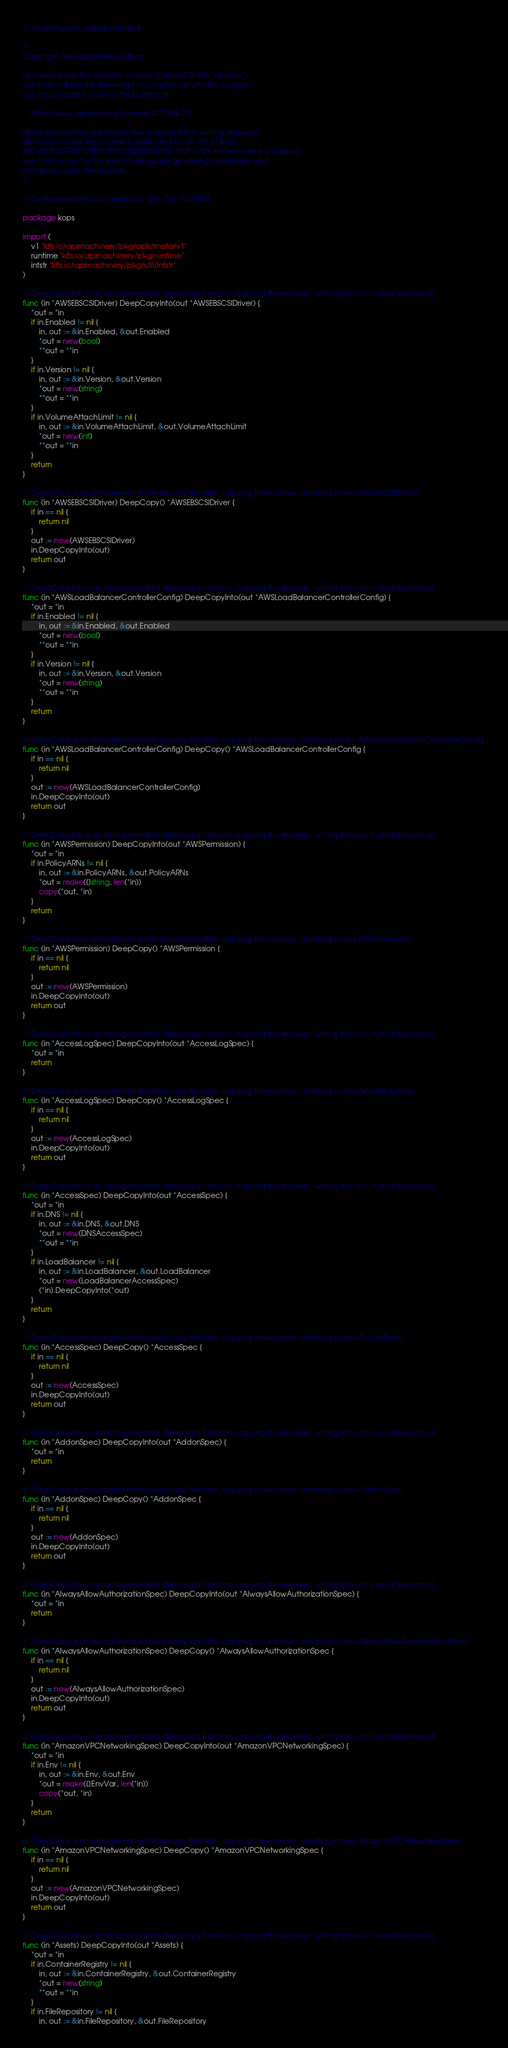Convert code to text. <code><loc_0><loc_0><loc_500><loc_500><_Go_>// +build !ignore_autogenerated

/*
Copyright The Kubernetes Authors.

Licensed under the Apache License, Version 2.0 (the "License");
you may not use this file except in compliance with the License.
You may obtain a copy of the License at

    http://www.apache.org/licenses/LICENSE-2.0

Unless required by applicable law or agreed to in writing, software
distributed under the License is distributed on an "AS IS" BASIS,
WITHOUT WARRANTIES OR CONDITIONS OF ANY KIND, either express or implied.
See the License for the specific language governing permissions and
limitations under the License.
*/

// Code generated by deepcopy-gen. DO NOT EDIT.

package kops

import (
	v1 "k8s.io/apimachinery/pkg/apis/meta/v1"
	runtime "k8s.io/apimachinery/pkg/runtime"
	intstr "k8s.io/apimachinery/pkg/util/intstr"
)

// DeepCopyInto is an autogenerated deepcopy function, copying the receiver, writing into out. in must be non-nil.
func (in *AWSEBSCSIDriver) DeepCopyInto(out *AWSEBSCSIDriver) {
	*out = *in
	if in.Enabled != nil {
		in, out := &in.Enabled, &out.Enabled
		*out = new(bool)
		**out = **in
	}
	if in.Version != nil {
		in, out := &in.Version, &out.Version
		*out = new(string)
		**out = **in
	}
	if in.VolumeAttachLimit != nil {
		in, out := &in.VolumeAttachLimit, &out.VolumeAttachLimit
		*out = new(int)
		**out = **in
	}
	return
}

// DeepCopy is an autogenerated deepcopy function, copying the receiver, creating a new AWSEBSCSIDriver.
func (in *AWSEBSCSIDriver) DeepCopy() *AWSEBSCSIDriver {
	if in == nil {
		return nil
	}
	out := new(AWSEBSCSIDriver)
	in.DeepCopyInto(out)
	return out
}

// DeepCopyInto is an autogenerated deepcopy function, copying the receiver, writing into out. in must be non-nil.
func (in *AWSLoadBalancerControllerConfig) DeepCopyInto(out *AWSLoadBalancerControllerConfig) {
	*out = *in
	if in.Enabled != nil {
		in, out := &in.Enabled, &out.Enabled
		*out = new(bool)
		**out = **in
	}
	if in.Version != nil {
		in, out := &in.Version, &out.Version
		*out = new(string)
		**out = **in
	}
	return
}

// DeepCopy is an autogenerated deepcopy function, copying the receiver, creating a new AWSLoadBalancerControllerConfig.
func (in *AWSLoadBalancerControllerConfig) DeepCopy() *AWSLoadBalancerControllerConfig {
	if in == nil {
		return nil
	}
	out := new(AWSLoadBalancerControllerConfig)
	in.DeepCopyInto(out)
	return out
}

// DeepCopyInto is an autogenerated deepcopy function, copying the receiver, writing into out. in must be non-nil.
func (in *AWSPermission) DeepCopyInto(out *AWSPermission) {
	*out = *in
	if in.PolicyARNs != nil {
		in, out := &in.PolicyARNs, &out.PolicyARNs
		*out = make([]string, len(*in))
		copy(*out, *in)
	}
	return
}

// DeepCopy is an autogenerated deepcopy function, copying the receiver, creating a new AWSPermission.
func (in *AWSPermission) DeepCopy() *AWSPermission {
	if in == nil {
		return nil
	}
	out := new(AWSPermission)
	in.DeepCopyInto(out)
	return out
}

// DeepCopyInto is an autogenerated deepcopy function, copying the receiver, writing into out. in must be non-nil.
func (in *AccessLogSpec) DeepCopyInto(out *AccessLogSpec) {
	*out = *in
	return
}

// DeepCopy is an autogenerated deepcopy function, copying the receiver, creating a new AccessLogSpec.
func (in *AccessLogSpec) DeepCopy() *AccessLogSpec {
	if in == nil {
		return nil
	}
	out := new(AccessLogSpec)
	in.DeepCopyInto(out)
	return out
}

// DeepCopyInto is an autogenerated deepcopy function, copying the receiver, writing into out. in must be non-nil.
func (in *AccessSpec) DeepCopyInto(out *AccessSpec) {
	*out = *in
	if in.DNS != nil {
		in, out := &in.DNS, &out.DNS
		*out = new(DNSAccessSpec)
		**out = **in
	}
	if in.LoadBalancer != nil {
		in, out := &in.LoadBalancer, &out.LoadBalancer
		*out = new(LoadBalancerAccessSpec)
		(*in).DeepCopyInto(*out)
	}
	return
}

// DeepCopy is an autogenerated deepcopy function, copying the receiver, creating a new AccessSpec.
func (in *AccessSpec) DeepCopy() *AccessSpec {
	if in == nil {
		return nil
	}
	out := new(AccessSpec)
	in.DeepCopyInto(out)
	return out
}

// DeepCopyInto is an autogenerated deepcopy function, copying the receiver, writing into out. in must be non-nil.
func (in *AddonSpec) DeepCopyInto(out *AddonSpec) {
	*out = *in
	return
}

// DeepCopy is an autogenerated deepcopy function, copying the receiver, creating a new AddonSpec.
func (in *AddonSpec) DeepCopy() *AddonSpec {
	if in == nil {
		return nil
	}
	out := new(AddonSpec)
	in.DeepCopyInto(out)
	return out
}

// DeepCopyInto is an autogenerated deepcopy function, copying the receiver, writing into out. in must be non-nil.
func (in *AlwaysAllowAuthorizationSpec) DeepCopyInto(out *AlwaysAllowAuthorizationSpec) {
	*out = *in
	return
}

// DeepCopy is an autogenerated deepcopy function, copying the receiver, creating a new AlwaysAllowAuthorizationSpec.
func (in *AlwaysAllowAuthorizationSpec) DeepCopy() *AlwaysAllowAuthorizationSpec {
	if in == nil {
		return nil
	}
	out := new(AlwaysAllowAuthorizationSpec)
	in.DeepCopyInto(out)
	return out
}

// DeepCopyInto is an autogenerated deepcopy function, copying the receiver, writing into out. in must be non-nil.
func (in *AmazonVPCNetworkingSpec) DeepCopyInto(out *AmazonVPCNetworkingSpec) {
	*out = *in
	if in.Env != nil {
		in, out := &in.Env, &out.Env
		*out = make([]EnvVar, len(*in))
		copy(*out, *in)
	}
	return
}

// DeepCopy is an autogenerated deepcopy function, copying the receiver, creating a new AmazonVPCNetworkingSpec.
func (in *AmazonVPCNetworkingSpec) DeepCopy() *AmazonVPCNetworkingSpec {
	if in == nil {
		return nil
	}
	out := new(AmazonVPCNetworkingSpec)
	in.DeepCopyInto(out)
	return out
}

// DeepCopyInto is an autogenerated deepcopy function, copying the receiver, writing into out. in must be non-nil.
func (in *Assets) DeepCopyInto(out *Assets) {
	*out = *in
	if in.ContainerRegistry != nil {
		in, out := &in.ContainerRegistry, &out.ContainerRegistry
		*out = new(string)
		**out = **in
	}
	if in.FileRepository != nil {
		in, out := &in.FileRepository, &out.FileRepository</code> 